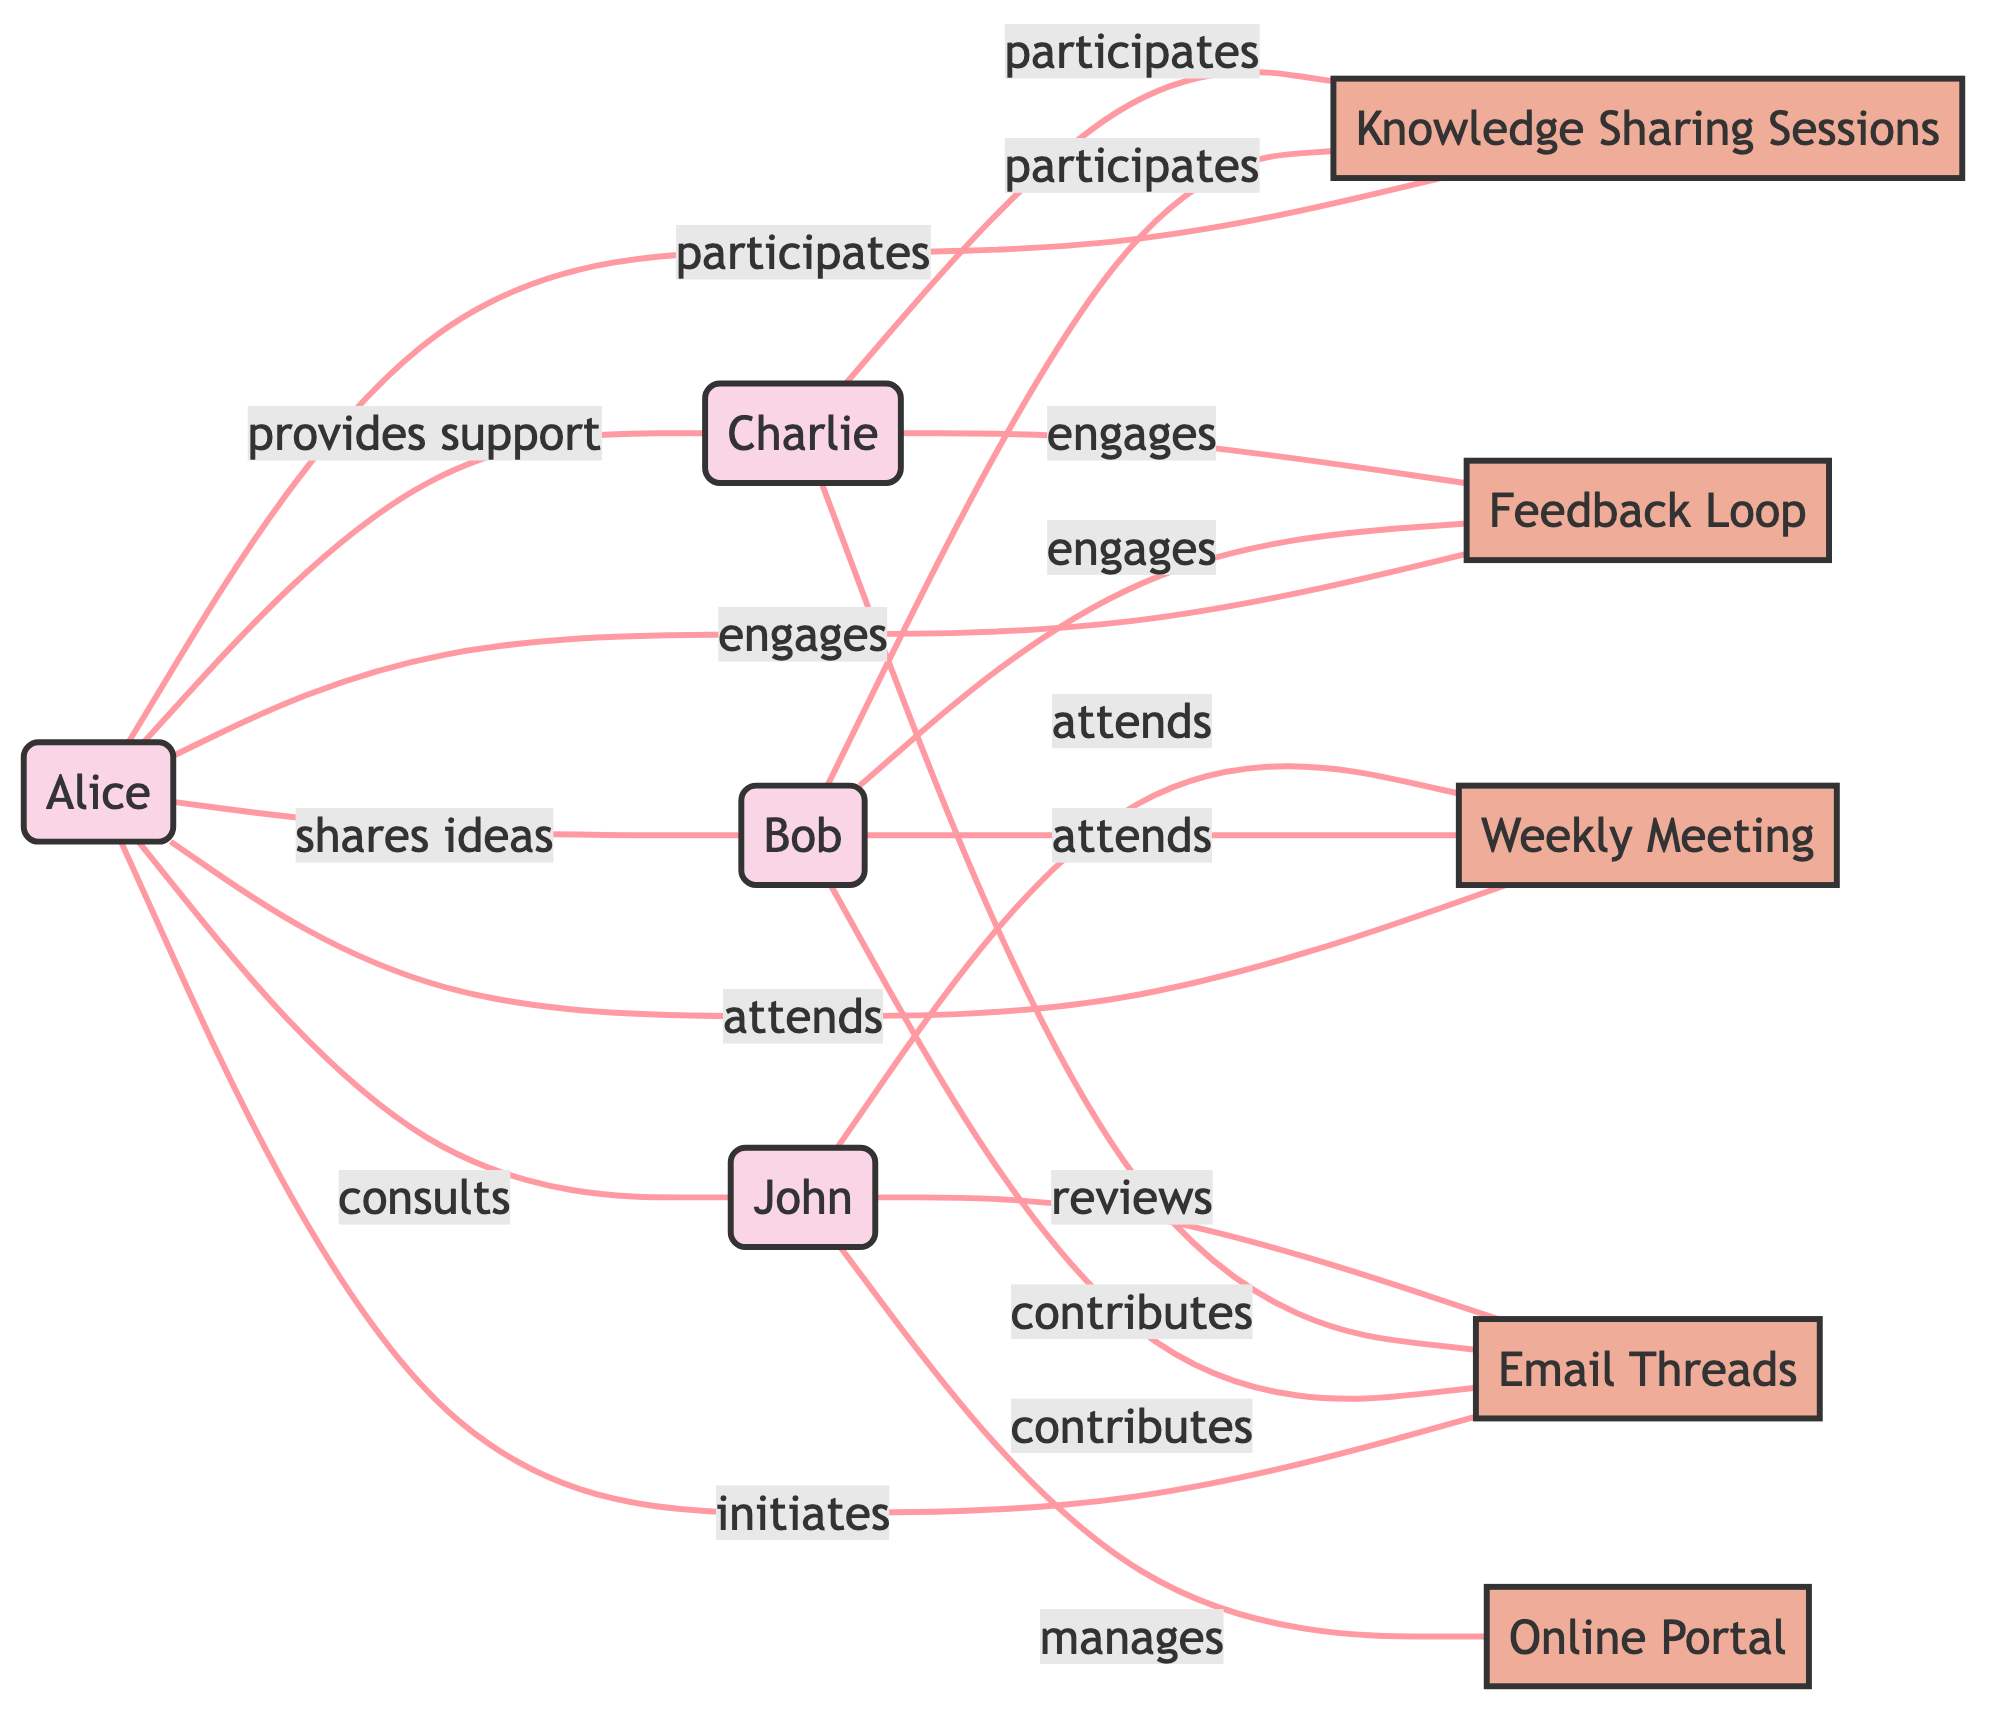What is the total number of nodes in the diagram? The diagram has a list of nodes, which includes Alice, Bob, Charlie, John, Knowledge Sharing Sessions, Weekly Meeting, Email Threads, Feedback Loop, and Online Portal. Counting these nodes gives a total of 9.
Answer: 9 How many edges are connected to Alice? By reviewing the edges connected to Alice, we see she has 6 connections: shares ideas with Bob, provides support to Charlie, participates in Knowledge Sharing Sessions, attends Weekly Meeting, initiates Email Threads, and engages in Feedback Loop. Therefore, the total is 6.
Answer: 6 Who contributes to the Email Threads? The edges indicate that Bob and Charlie contribute to Email Threads. Therefore, the answer is Bob and Charlie.
Answer: Bob and Charlie Which technique is John responsible for managing? The edge indicates that John manages the Online Portal, showing that his responsibility is clearly defined.
Answer: Online Portal How many people attend the Weekly Meeting? The edges indicate that Alice, Bob, and John all attend the Weekly Meeting. Therefore, we can count three attendees.
Answer: 3 Which node has the most connections? By examining the connections, we see that Alice is connected to 6 edges, making her the node with the most connections compared to others.
Answer: Alice How do Bob and Charlie engage with the Feedback Loop? Both Bob and Charlie are engaged in the Feedback Loop according to the edges shown. Each person is connected to this node directly.
Answer: Engages What action does Alice take towards John? The edge shows that Alice consults John, signifying a supportive action directed towards him.
Answer: consults How many techniques are represented in the graph? The graph displays five techniques: Knowledge Sharing Sessions, Weekly Meeting, Email Threads, Feedback Loop, and Online Portal. Counting them gives us a total of 5 techniques.
Answer: 5 